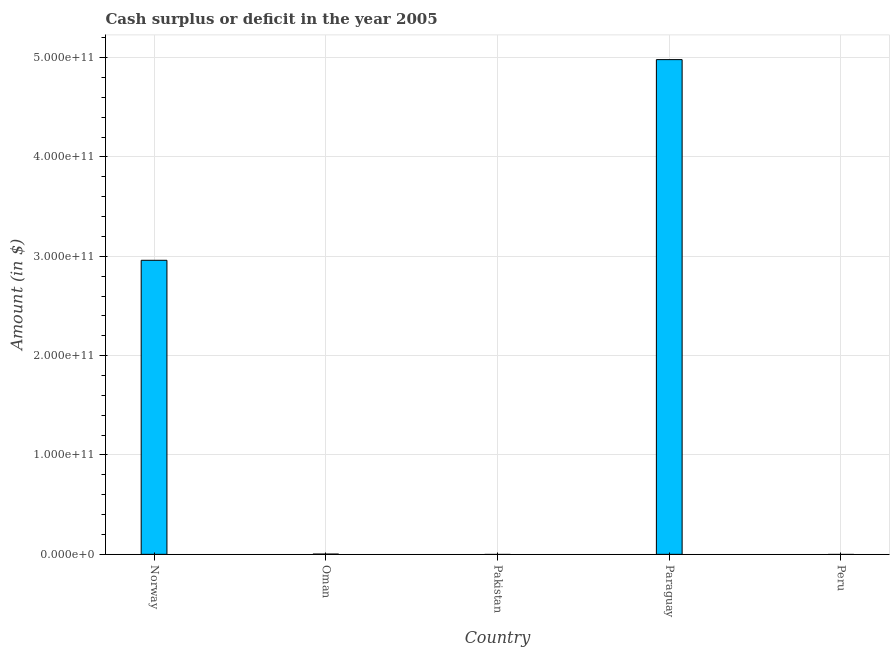Does the graph contain any zero values?
Ensure brevity in your answer.  Yes. What is the title of the graph?
Keep it short and to the point. Cash surplus or deficit in the year 2005. What is the label or title of the X-axis?
Keep it short and to the point. Country. What is the label or title of the Y-axis?
Offer a terse response. Amount (in $). What is the cash surplus or deficit in Norway?
Offer a terse response. 2.96e+11. Across all countries, what is the maximum cash surplus or deficit?
Give a very brief answer. 4.98e+11. In which country was the cash surplus or deficit maximum?
Your answer should be very brief. Paraguay. What is the sum of the cash surplus or deficit?
Provide a succinct answer. 7.94e+11. What is the difference between the cash surplus or deficit in Oman and Paraguay?
Offer a terse response. -4.98e+11. What is the average cash surplus or deficit per country?
Your answer should be compact. 1.59e+11. What is the median cash surplus or deficit?
Your answer should be very brief. 2.66e+08. Is the difference between the cash surplus or deficit in Norway and Paraguay greater than the difference between any two countries?
Give a very brief answer. No. What is the difference between the highest and the second highest cash surplus or deficit?
Keep it short and to the point. 2.02e+11. What is the difference between the highest and the lowest cash surplus or deficit?
Your answer should be very brief. 4.98e+11. In how many countries, is the cash surplus or deficit greater than the average cash surplus or deficit taken over all countries?
Your answer should be very brief. 2. What is the difference between two consecutive major ticks on the Y-axis?
Your response must be concise. 1.00e+11. Are the values on the major ticks of Y-axis written in scientific E-notation?
Your response must be concise. Yes. What is the Amount (in $) of Norway?
Provide a succinct answer. 2.96e+11. What is the Amount (in $) in Oman?
Keep it short and to the point. 2.66e+08. What is the Amount (in $) of Paraguay?
Provide a short and direct response. 4.98e+11. What is the difference between the Amount (in $) in Norway and Oman?
Keep it short and to the point. 2.96e+11. What is the difference between the Amount (in $) in Norway and Paraguay?
Ensure brevity in your answer.  -2.02e+11. What is the difference between the Amount (in $) in Oman and Paraguay?
Offer a terse response. -4.98e+11. What is the ratio of the Amount (in $) in Norway to that in Oman?
Your answer should be compact. 1114.43. What is the ratio of the Amount (in $) in Norway to that in Paraguay?
Your answer should be compact. 0.59. 